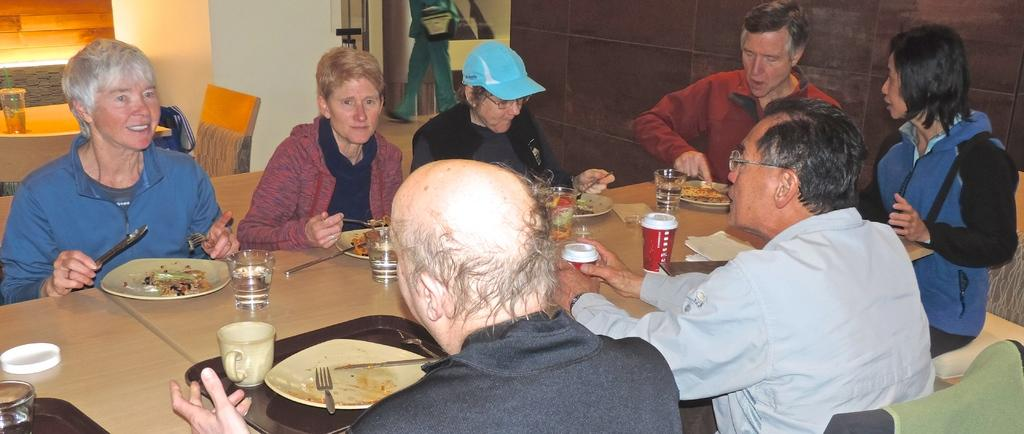What are the people in the image doing? The people in the image are sitting around a table. What are the people sitting on? The people are sitting on chairs. What activity are the people engaged in while sitting at the table? The people are having their food. What can be found on the table in the image? There is food, glasses, a cup, a fork, a knife, and a spoon on the table. How many brains are visible on the table in the image? There are no brains visible on the table in the image. Are there any servants present in the image? There is no mention of servants in the image; it only shows people sitting around a table having their food. 